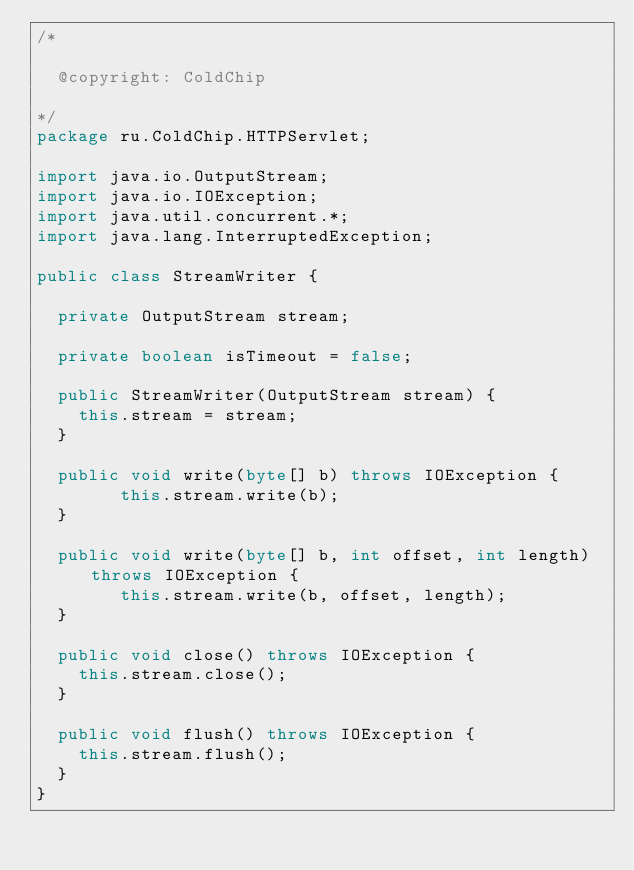<code> <loc_0><loc_0><loc_500><loc_500><_Java_>/*

	@copyright: ColdChip

*/
package ru.ColdChip.HTTPServlet;

import java.io.OutputStream;
import java.io.IOException;
import java.util.concurrent.*;
import java.lang.InterruptedException;

public class StreamWriter {

	private OutputStream stream;

	private boolean isTimeout = false;

	public StreamWriter(OutputStream stream) {
		this.stream = stream;
	}

	public void write(byte[] b) throws IOException {
        this.stream.write(b);
	}

	public void write(byte[] b, int offset, int length) throws IOException {
        this.stream.write(b, offset, length);
	}

	public void close() throws IOException {
		this.stream.close();
	}

	public void flush() throws IOException {
		this.stream.flush();
	}
}</code> 